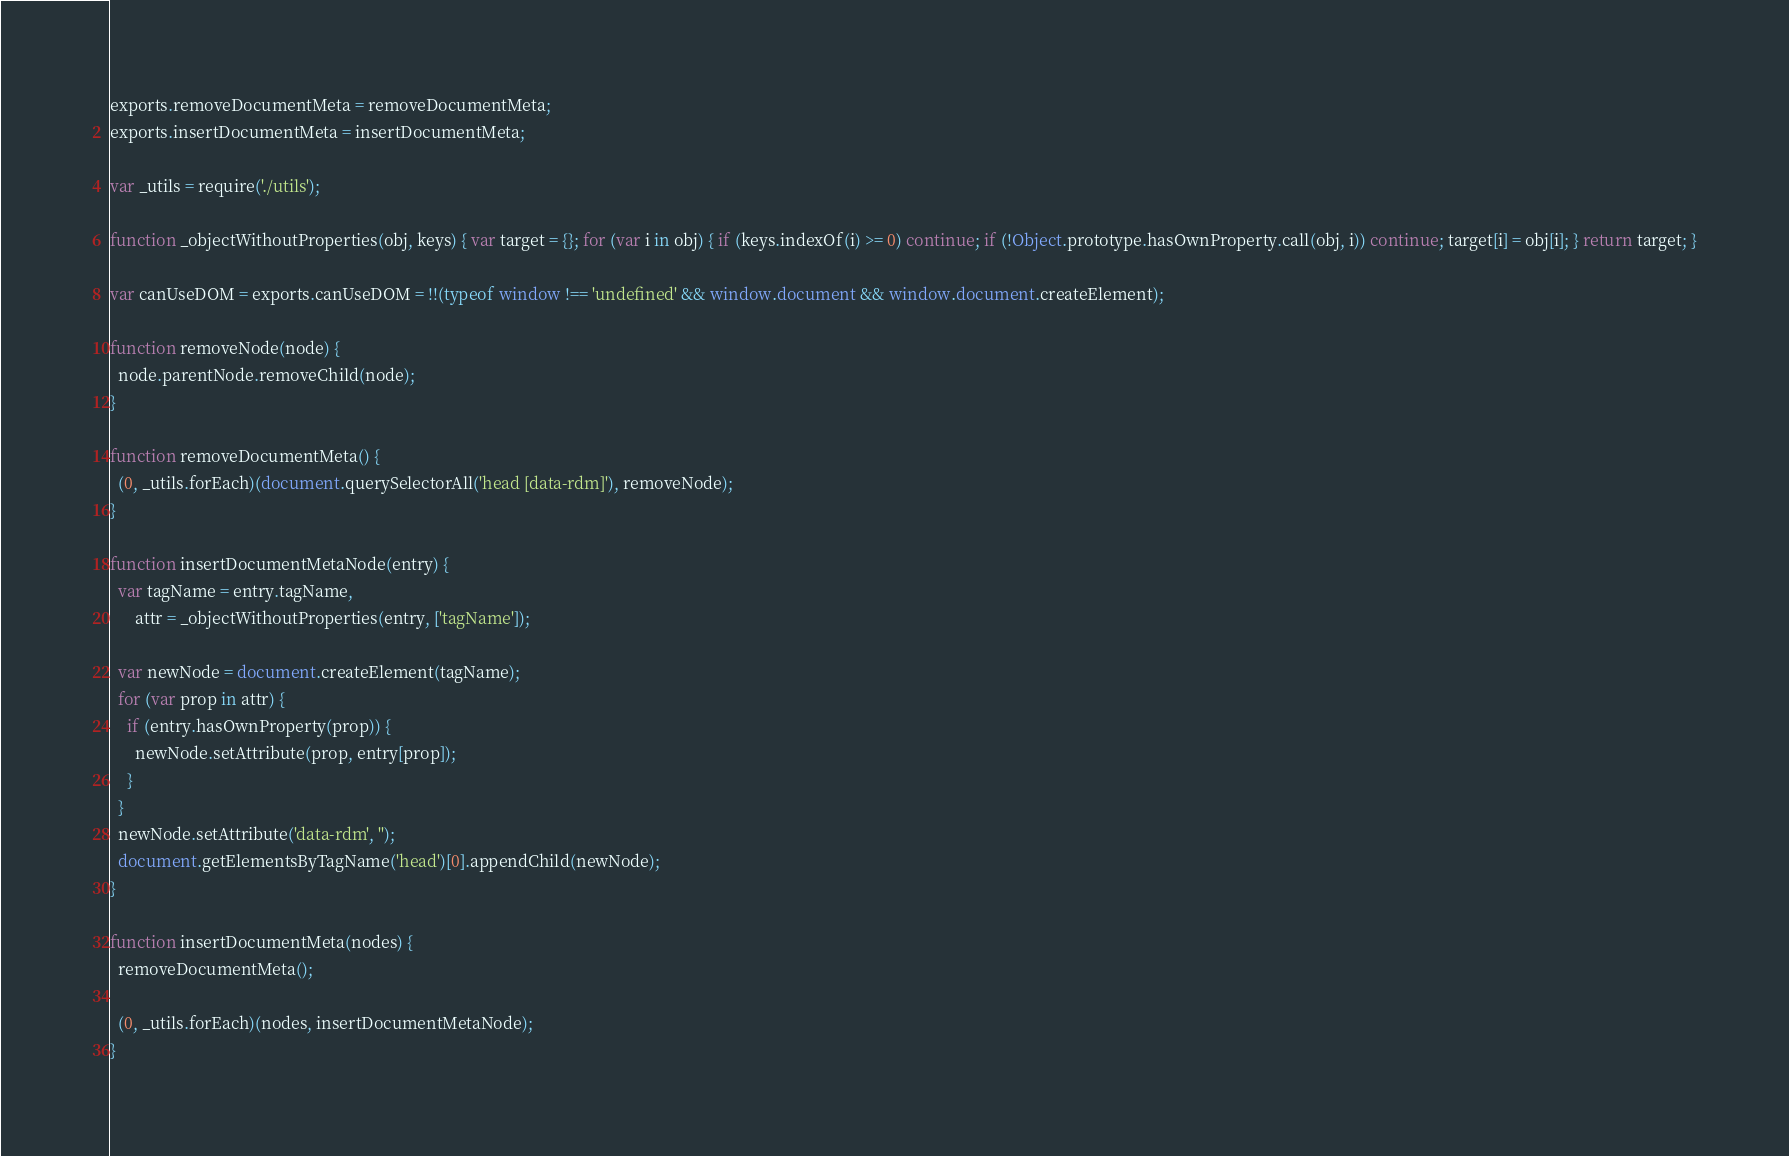<code> <loc_0><loc_0><loc_500><loc_500><_JavaScript_>exports.removeDocumentMeta = removeDocumentMeta;
exports.insertDocumentMeta = insertDocumentMeta;

var _utils = require('./utils');

function _objectWithoutProperties(obj, keys) { var target = {}; for (var i in obj) { if (keys.indexOf(i) >= 0) continue; if (!Object.prototype.hasOwnProperty.call(obj, i)) continue; target[i] = obj[i]; } return target; }

var canUseDOM = exports.canUseDOM = !!(typeof window !== 'undefined' && window.document && window.document.createElement);

function removeNode(node) {
  node.parentNode.removeChild(node);
}

function removeDocumentMeta() {
  (0, _utils.forEach)(document.querySelectorAll('head [data-rdm]'), removeNode);
}

function insertDocumentMetaNode(entry) {
  var tagName = entry.tagName,
      attr = _objectWithoutProperties(entry, ['tagName']);

  var newNode = document.createElement(tagName);
  for (var prop in attr) {
    if (entry.hasOwnProperty(prop)) {
      newNode.setAttribute(prop, entry[prop]);
    }
  }
  newNode.setAttribute('data-rdm', '');
  document.getElementsByTagName('head')[0].appendChild(newNode);
}

function insertDocumentMeta(nodes) {
  removeDocumentMeta();

  (0, _utils.forEach)(nodes, insertDocumentMetaNode);
}
</code> 